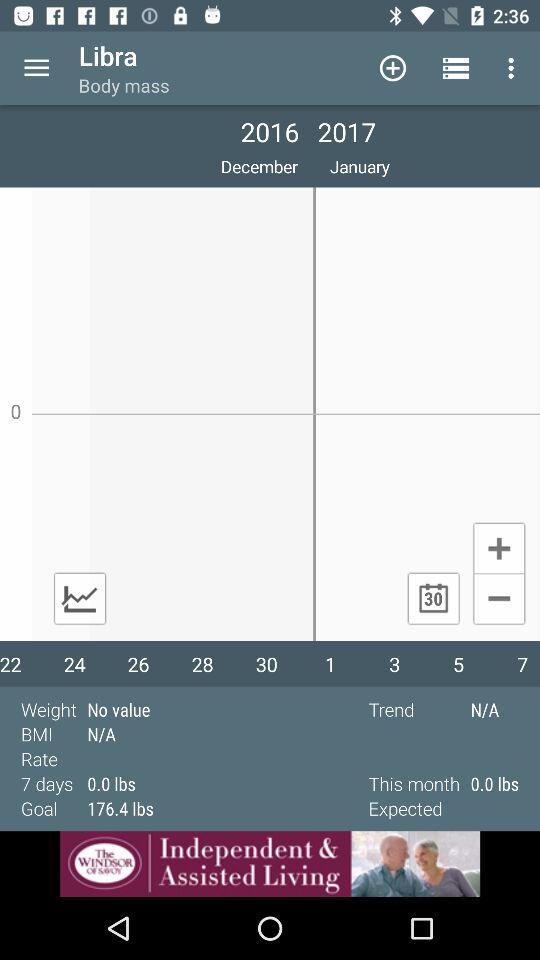What is the average weight change for the past 7 days?
Answer the question using a single word or phrase. 0.0 lbs 